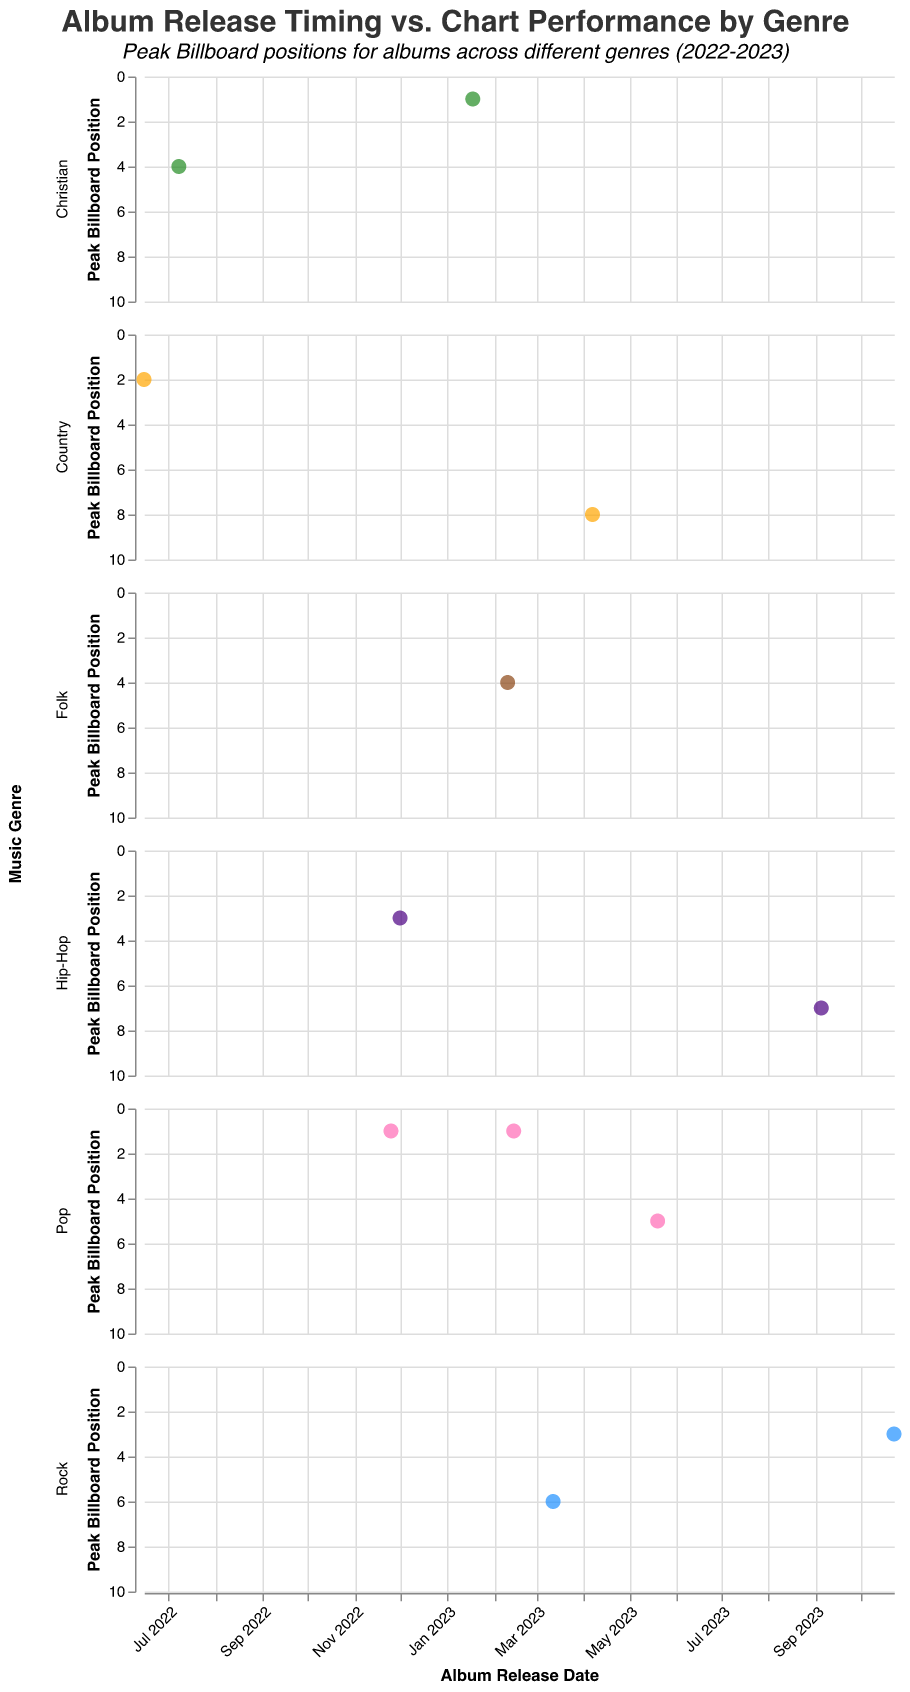What's the title of the figure? The title of the figure is displayed at the top center of the chart. The main title is “Album Release Timing vs. Chart Performance by Genre” and the subtitle is “Peak Billboard positions for albums across different genres (2022-2023)”.
Answer: "Album Release Timing vs. Chart Performance by Genre" What is the album with the best chart performance in the Pop genre? To find the best-performing Pop album, look for the data point with the lowest Peak Billboard Position in the Pop genre subplot. The data point with the Peak Billboard Position of 1 in the Pop genre subplot belongs to Ed Sheeran's “Mathematics”.
Answer: "Mathematics" by Ed Sheeran Which genre has the highest number of albums that reached the #1 position on the Billboard chart? To determine this, count the number of data points with a Peak Billboard Position of 1 in each genre’s subplot. In the diagram, Pop, Christian, and Hip-Hop genres each have one data point with a Peak Billboard Position of 1.
Answer: Tie between Pop and Christian Which album was released the latest, and what is its chart performance? Check for the right-most data point in the subplots, which corresponds to the most recent release date. The most recent album release is "Pressure Machine" by The Killers in the Rock genre, dated 2023-10-23, with a Peak Billboard Position of 3.
Answer: "Pressure Machine" by The Killers, Peak Billboard Position: 3 How many albums released in 2023 reached a Peak Billboard Position of 3 or higher? Identify the albums released in 2023 and then count how many of them have a Peak Billboard Position of 3 or better. The relevant albums are "Mathematics", "In These Silent Days", "17 going under", "Pressure Machine", and "Graves into Gardens". There are five such albums.
Answer: 5 What is the average Peak Billboard Position of albums in the Rock genre? First, list the Peak Billboard Positions of albums in the Rock genre: 6 ("17 going under") and 3 ("Pressure Machine"). Calculate the average: (6 + 3) / 2 = 4.5.
Answer: 4.5 Compare the chart performance of Pop and Country genres. Which one performed better on average? Calculate the average Peak Billboard Position for both genres: Pop (1, 1, 5) = (1+1+5)/3 = 2.33, Country (2, 8) = (2+8)/2 = 5. Pop genre has a lower (better) average Peak Billboard Position.
Answer: Pop genre 